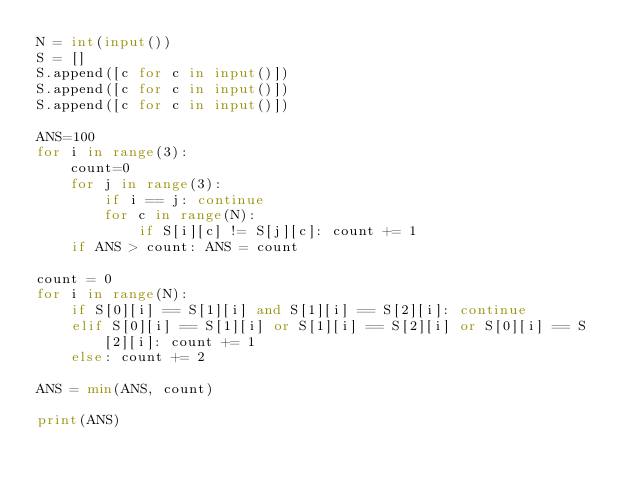<code> <loc_0><loc_0><loc_500><loc_500><_Python_>N = int(input())
S = []
S.append([c for c in input()])
S.append([c for c in input()])
S.append([c for c in input()])

ANS=100
for i in range(3):
    count=0
    for j in range(3):
        if i == j: continue
        for c in range(N):
            if S[i][c] != S[j][c]: count += 1
    if ANS > count: ANS = count

count = 0
for i in range(N):
    if S[0][i] == S[1][i] and S[1][i] == S[2][i]: continue
    elif S[0][i] == S[1][i] or S[1][i] == S[2][i] or S[0][i] == S[2][i]: count += 1
    else: count += 2

ANS = min(ANS, count)

print(ANS)
</code> 